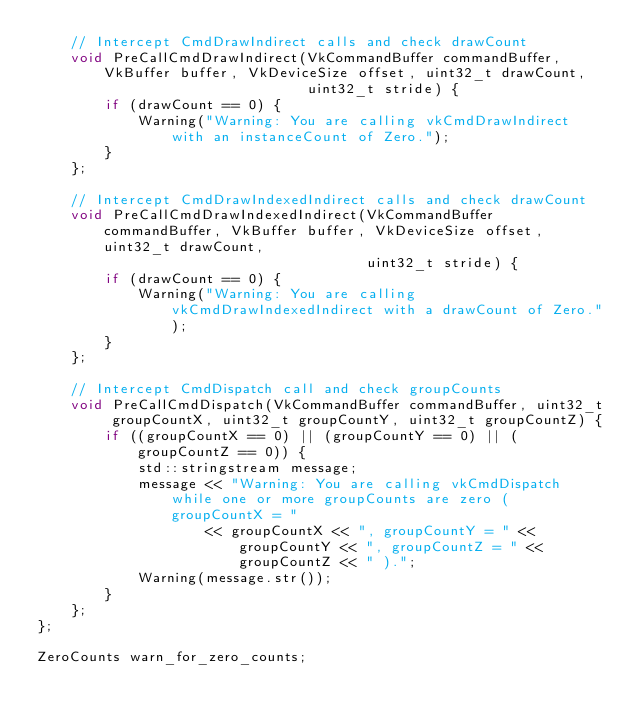Convert code to text. <code><loc_0><loc_0><loc_500><loc_500><_C_>    // Intercept CmdDrawIndirect calls and check drawCount
    void PreCallCmdDrawIndirect(VkCommandBuffer commandBuffer, VkBuffer buffer, VkDeviceSize offset, uint32_t drawCount,
                                uint32_t stride) {
        if (drawCount == 0) {
            Warning("Warning: You are calling vkCmdDrawIndirect with an instanceCount of Zero.");
        }
    };

    // Intercept CmdDrawIndexedIndirect calls and check drawCount
    void PreCallCmdDrawIndexedIndirect(VkCommandBuffer commandBuffer, VkBuffer buffer, VkDeviceSize offset, uint32_t drawCount,
                                       uint32_t stride) {
        if (drawCount == 0) {
            Warning("Warning: You are calling vkCmdDrawIndexedIndirect with a drawCount of Zero.");
        }
    };

    // Intercept CmdDispatch call and check groupCounts
    void PreCallCmdDispatch(VkCommandBuffer commandBuffer, uint32_t groupCountX, uint32_t groupCountY, uint32_t groupCountZ) {
        if ((groupCountX == 0) || (groupCountY == 0) || (groupCountZ == 0)) {
            std::stringstream message;
            message << "Warning: You are calling vkCmdDispatch while one or more groupCounts are zero ( groupCountX = "
                    << groupCountX << ", groupCountY = " << groupCountY << ", groupCountZ = " << groupCountZ << " ).";
            Warning(message.str());
        }
    };
};

ZeroCounts warn_for_zero_counts;
</code> 